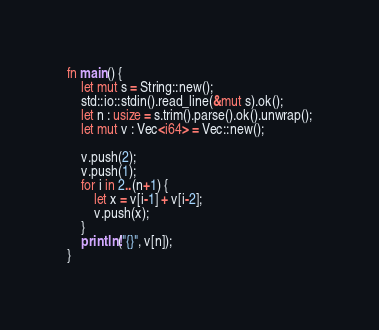Convert code to text. <code><loc_0><loc_0><loc_500><loc_500><_Rust_>fn main() {
    let mut s = String::new();
    std::io::stdin().read_line(&mut s).ok();
    let n : usize = s.trim().parse().ok().unwrap();
    let mut v : Vec<i64> = Vec::new();

    v.push(2);
    v.push(1);
    for i in 2..(n+1) {
        let x = v[i-1] + v[i-2];
        v.push(x);
    }
    println!("{}", v[n]);
}
</code> 